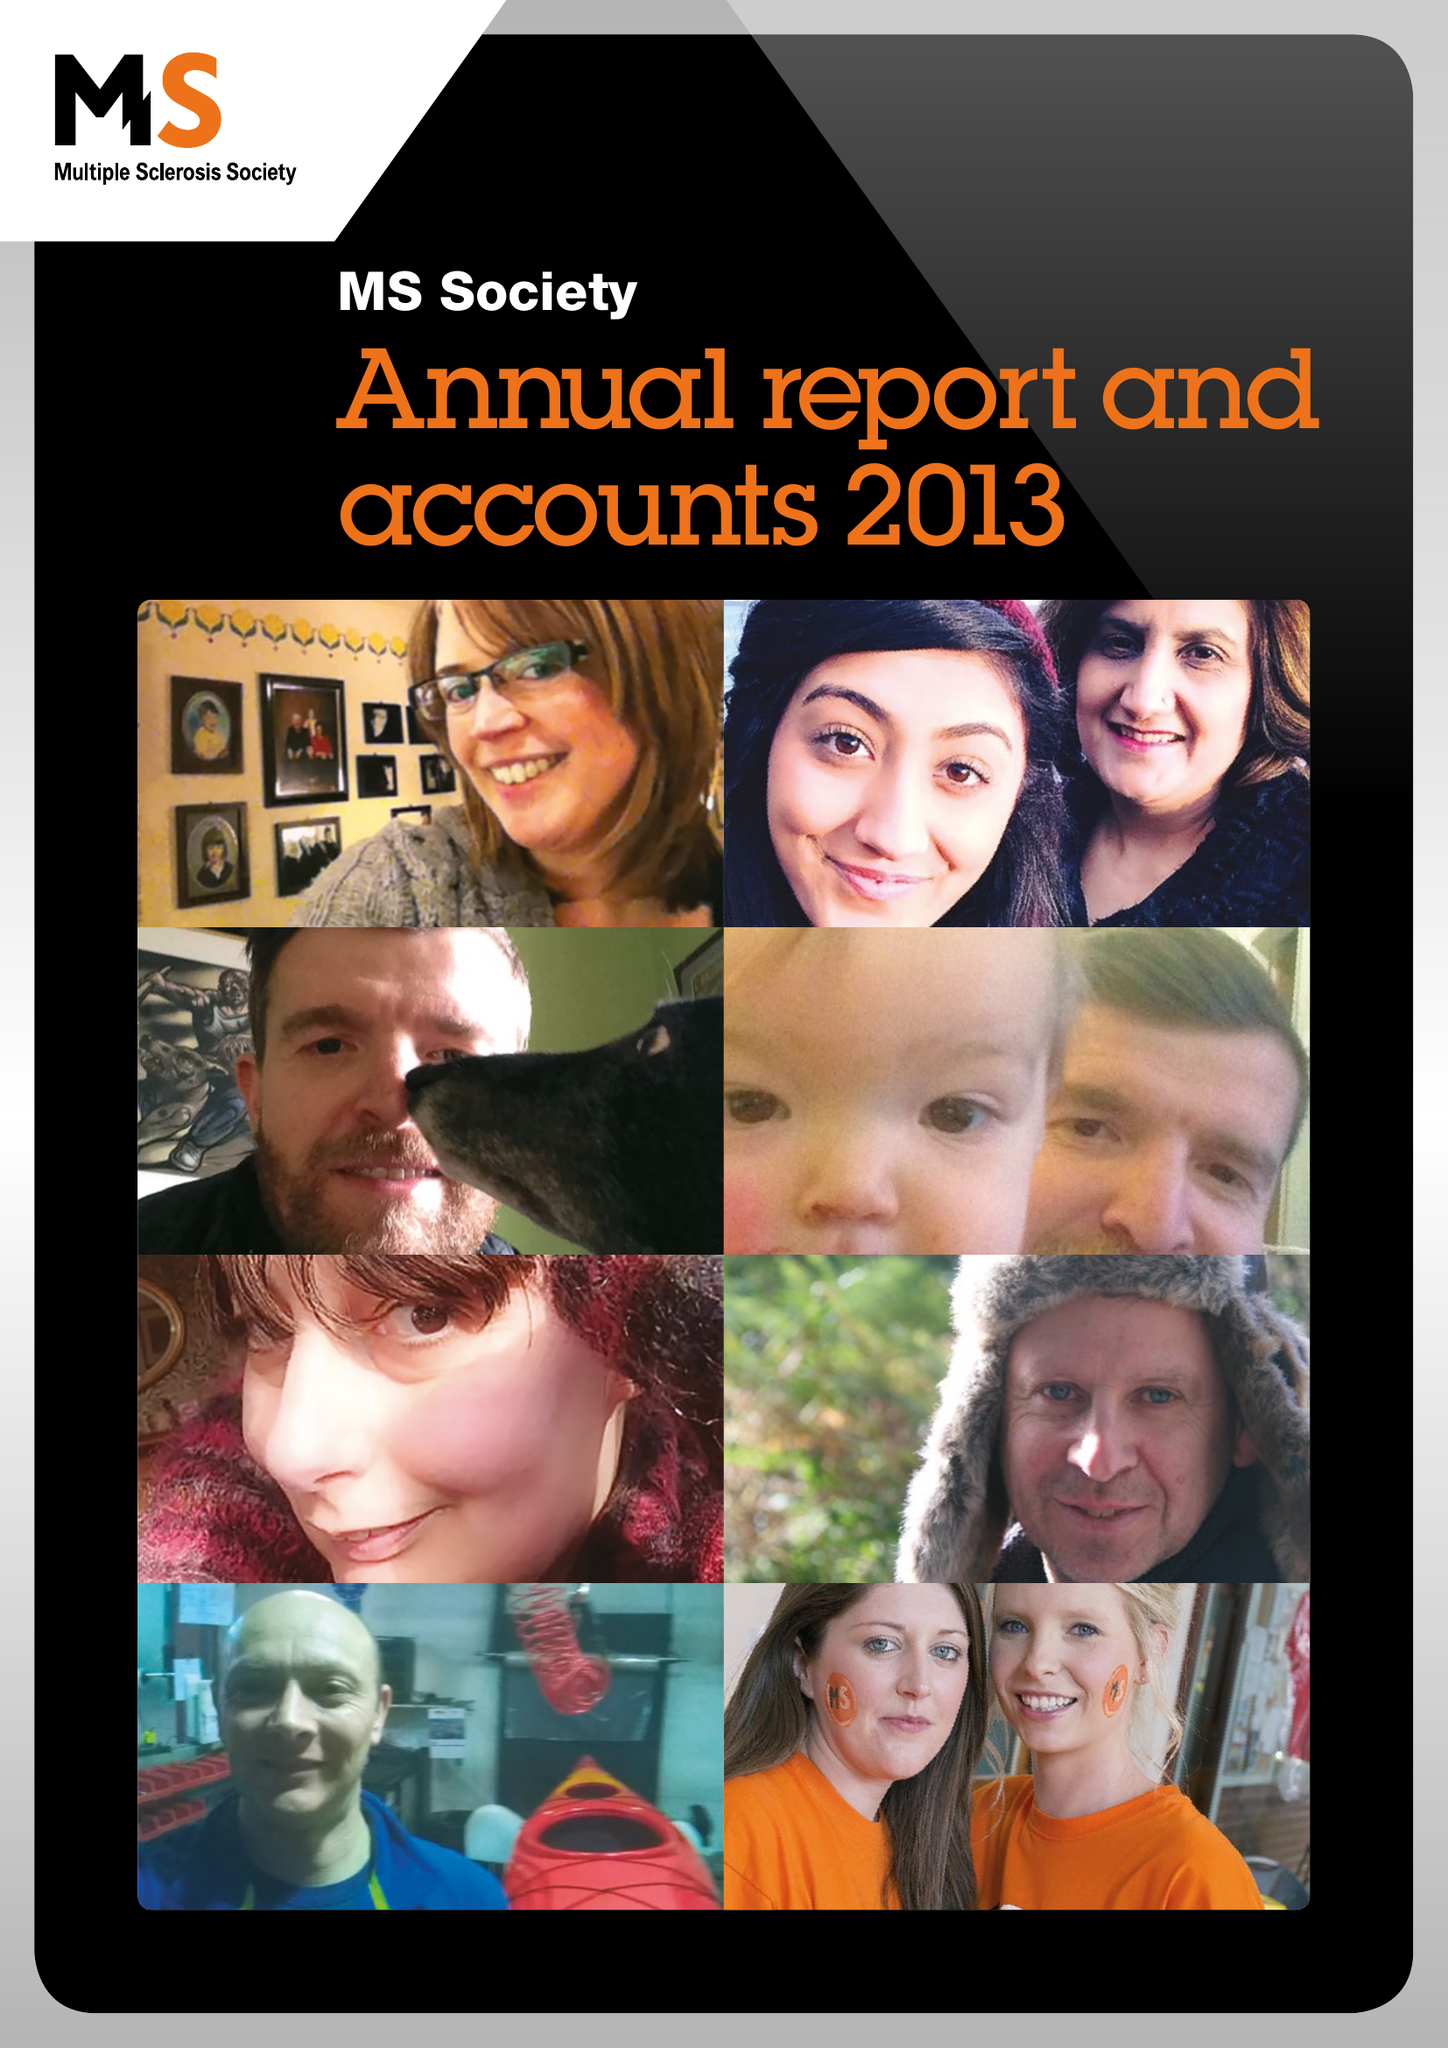What is the value for the charity_number?
Answer the question using a single word or phrase. 1139257 